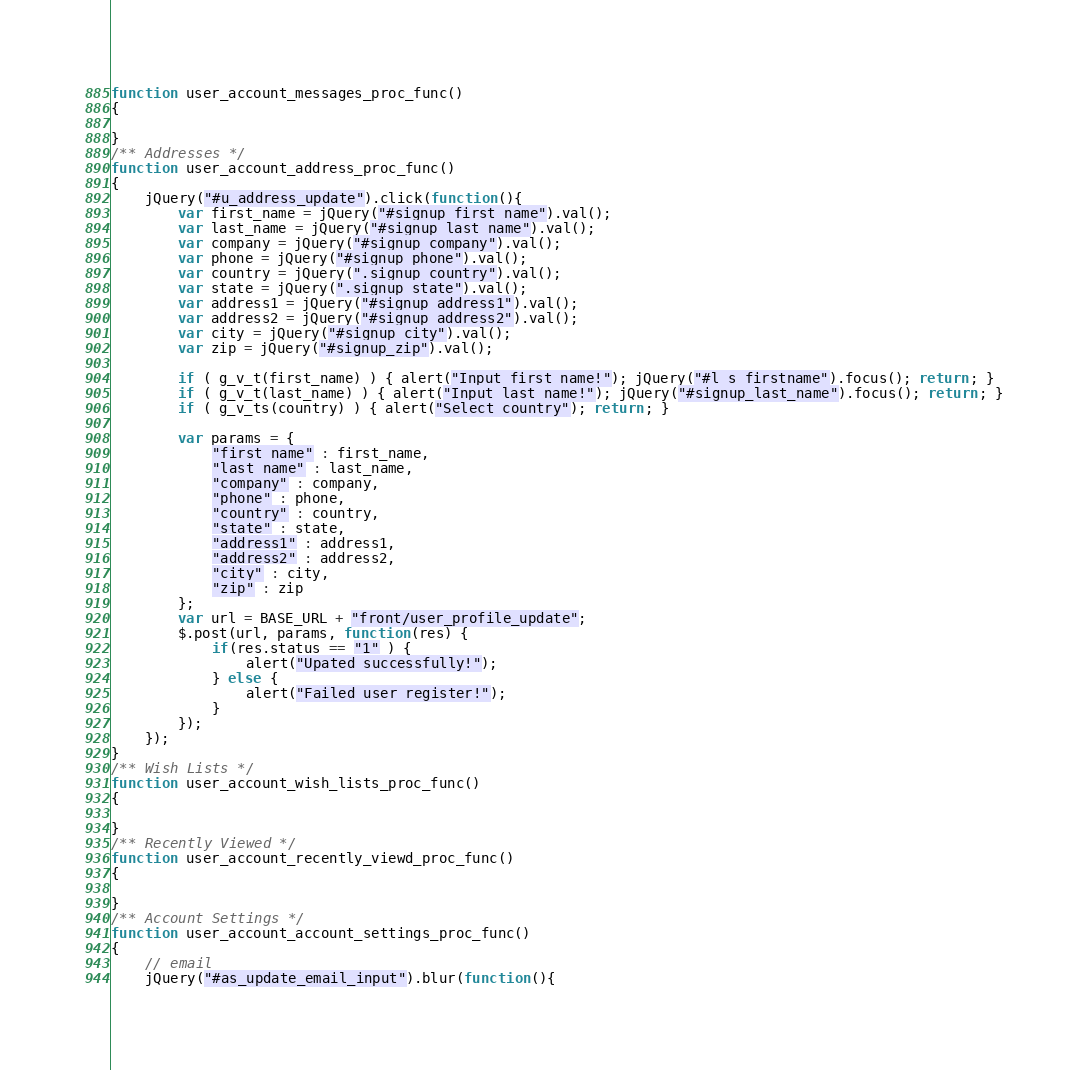Convert code to text. <code><loc_0><loc_0><loc_500><loc_500><_JavaScript_>function user_account_messages_proc_func()
{

}
/** Addresses */
function user_account_address_proc_func()
{
    jQuery("#u_address_update").click(function(){
        var first_name = jQuery("#signup_first_name").val();
        var last_name = jQuery("#signup_last_name").val();
        var company = jQuery("#signup_company").val();
        var phone = jQuery("#signup_phone").val();
        var country = jQuery(".signup_country").val();
        var state = jQuery(".signup_state").val();
        var address1 = jQuery("#signup_address1").val();
        var address2 = jQuery("#signup_address2").val();
        var city = jQuery("#signup_city").val();
        var zip = jQuery("#signup_zip").val();

        if ( g_v_t(first_name) ) { alert("Input first name!"); jQuery("#l_s_firstname").focus(); return; }
        if ( g_v_t(last_name) ) { alert("Input last name!"); jQuery("#signup_last_name").focus(); return; }
        if ( g_v_ts(country) ) { alert("Select country"); return; }

        var params = {
            "first_name" : first_name,
            "last_name" : last_name,
            "company" : company,
            "phone" : phone,
            "country" : country,
            "state" : state,
            "address1" : address1,
            "address2" : address2,
            "city" : city,
            "zip" : zip
        };
        var url = BASE_URL + "front/user_profile_update";
        $.post(url, params, function(res) {
            if(res.status == "1" ) {
                alert("Upated successfully!");
            } else {
                alert("Failed user register!");
            }
        });
    });
}
/** Wish Lists */
function user_account_wish_lists_proc_func()
{

}
/** Recently Viewed */
function user_account_recently_viewd_proc_func()
{

}
/** Account Settings */
function user_account_account_settings_proc_func()
{
    // email
    jQuery("#as_update_email_input").blur(function(){</code> 